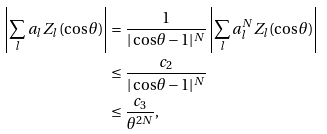<formula> <loc_0><loc_0><loc_500><loc_500>\left | \sum _ { l } a _ { l } Z _ { l } ( \cos \theta ) \right | & = \frac { 1 } { | \cos \theta - 1 | ^ { N } } \left | \sum _ { l } a _ { l } ^ { N } Z _ { l } ( \cos \theta ) \right | \\ & \leq \frac { c _ { 2 } } { | \cos \theta - 1 | ^ { N } } \\ & \leq \frac { c _ { 3 } } { \theta ^ { 2 N } } ,</formula> 